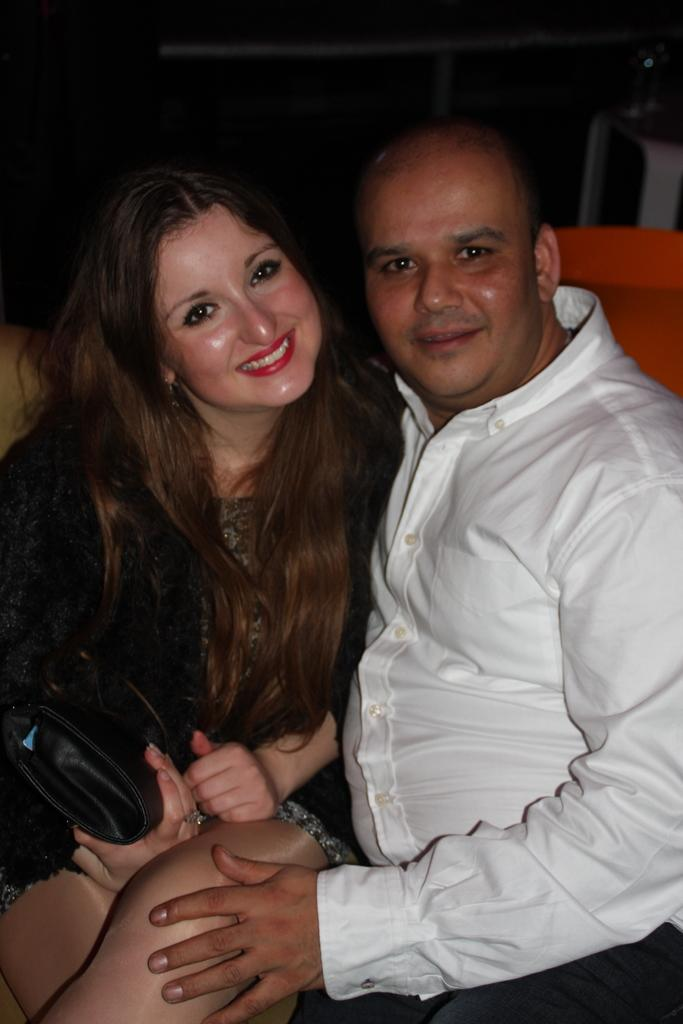How many people are sitting in the image? There are two people sitting in the image. What is the person on the left wearing? The person on the left is wearing a white shirt. What is the person on the right wearing? The person on the right is wearing a dress. What is the person on the right holding? The person on the right is holding a bag in her hand. What is the facial expression of the person on the right? The person on the right is smiling. What type of food is being prepared by the person on the left in the image? There is no indication of food or cooking in the image; the person on the left is simply sitting and wearing a white shirt. Is there a bathtub visible in the image? No, there is no bathtub or any reference to bathing in the image. 